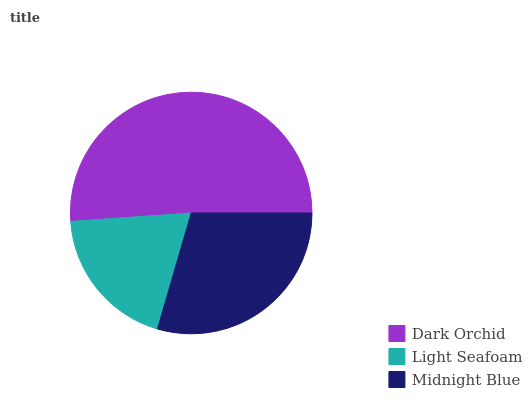Is Light Seafoam the minimum?
Answer yes or no. Yes. Is Dark Orchid the maximum?
Answer yes or no. Yes. Is Midnight Blue the minimum?
Answer yes or no. No. Is Midnight Blue the maximum?
Answer yes or no. No. Is Midnight Blue greater than Light Seafoam?
Answer yes or no. Yes. Is Light Seafoam less than Midnight Blue?
Answer yes or no. Yes. Is Light Seafoam greater than Midnight Blue?
Answer yes or no. No. Is Midnight Blue less than Light Seafoam?
Answer yes or no. No. Is Midnight Blue the high median?
Answer yes or no. Yes. Is Midnight Blue the low median?
Answer yes or no. Yes. Is Dark Orchid the high median?
Answer yes or no. No. Is Dark Orchid the low median?
Answer yes or no. No. 